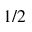<formula> <loc_0><loc_0><loc_500><loc_500>1 / 2</formula> 